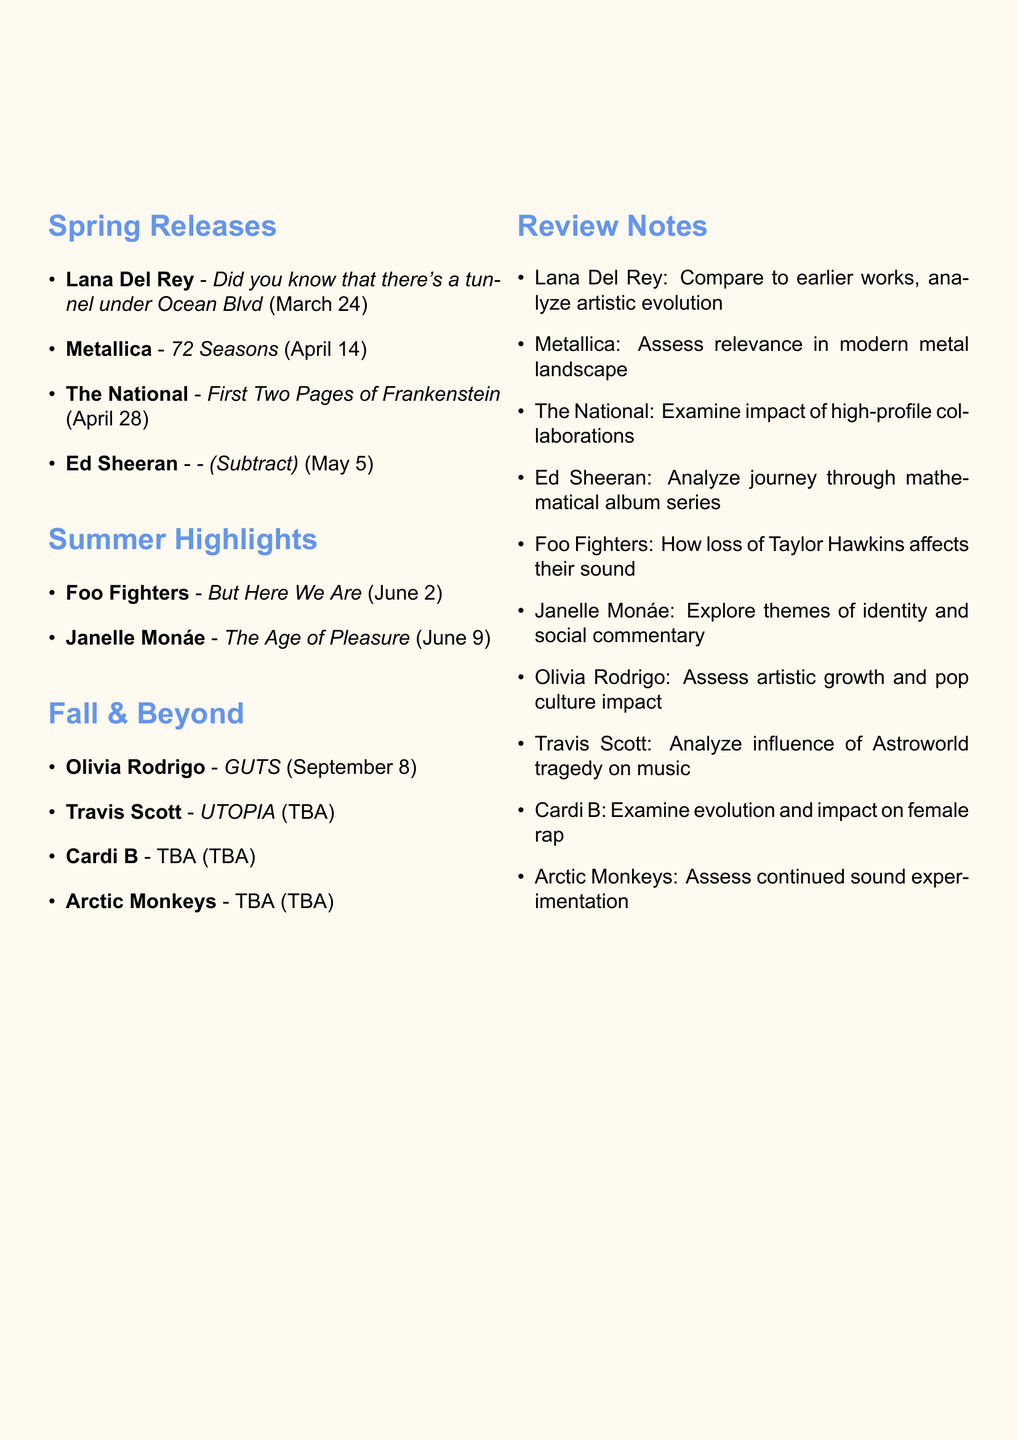What is the release date of Lana Del Rey's album? The document states that Lana Del Rey's album "Did you know that there's a tunnel under Ocean Blvd" is set to be released on March 24, 2023.
Answer: March 24, 2023 Which band is releasing an album called "72 Seasons"? The document includes information about "72 Seasons" by Metallica, allowing us to identify the band associated with this title.
Answer: Metallica What is the name of Olivia Rodrigo's upcoming album? The document indicates that Olivia Rodrigo's sophomore album is titled "GUTS."
Answer: GUTS How many albums are listed for release in Spring? Counting the albums under the Spring Releases section shows there are four albums mentioned.
Answer: Four What is a significant theme explored in Janelle Monáe's album? According to the document, Janelle Monáe's album "The Age of Pleasure" explores themes of identity and social commentary.
Answer: Identity and social commentary What notable collaboration is featured in The National's upcoming album? The document notes that The National's album features collaborations with Taylor Swift and Sufjan Stevens, indicating significant partnerships.
Answer: Taylor Swift and Sufjan Stevens When was the last studio album released by Metallica before "72 Seasons"? The document mentions that "72 Seasons" is Metallica's first studio album in seven years, allowing us to infer when their previous album was released.
Answer: 2016 Which two artists have TBA albums? The document indicates that both Travis Scott and Cardi B have albums listed as TBA.
Answer: Travis Scott and Cardi B What type of album is Ed Sheeran's "-" considered? The document states that it is the final installment in Ed Sheeran's mathematical album series, giving it a specific classification.
Answer: Mathematical album series 